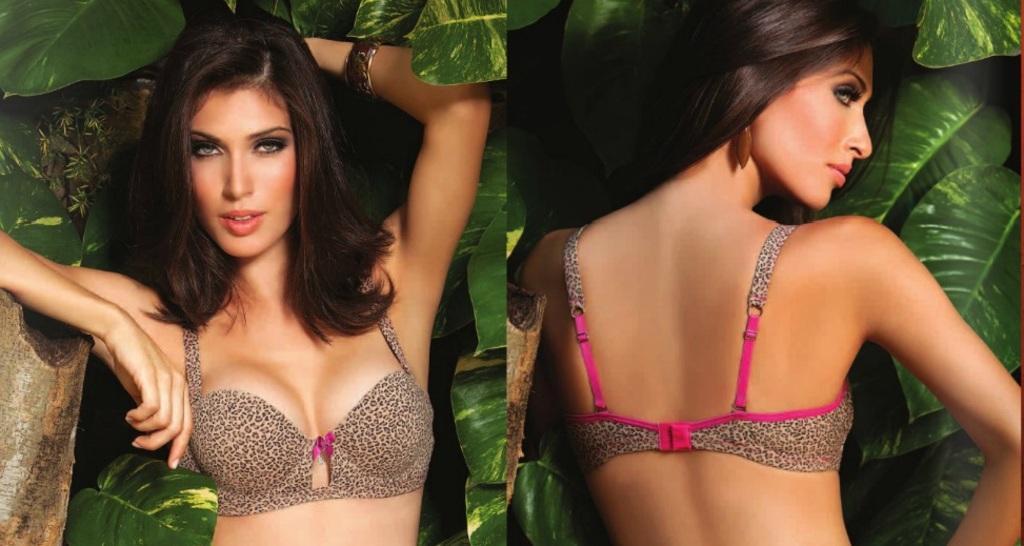In one or two sentences, can you explain what this image depicts? There is a collage image of two different pictures of a same person. In the first picture, we can see a person front view. In the second picture, we can see a person back view. 